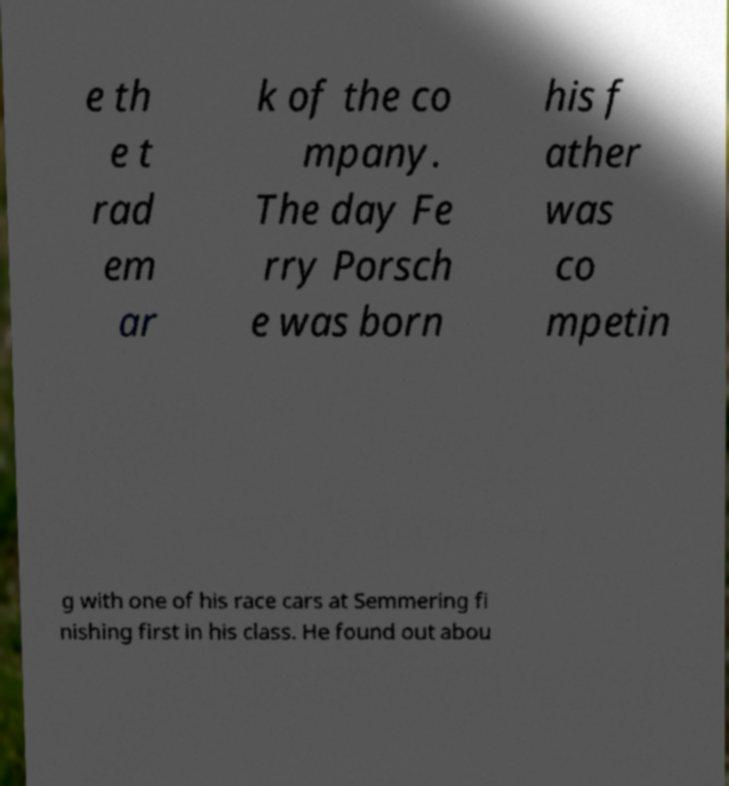Can you read and provide the text displayed in the image?This photo seems to have some interesting text. Can you extract and type it out for me? e th e t rad em ar k of the co mpany. The day Fe rry Porsch e was born his f ather was co mpetin g with one of his race cars at Semmering fi nishing first in his class. He found out abou 